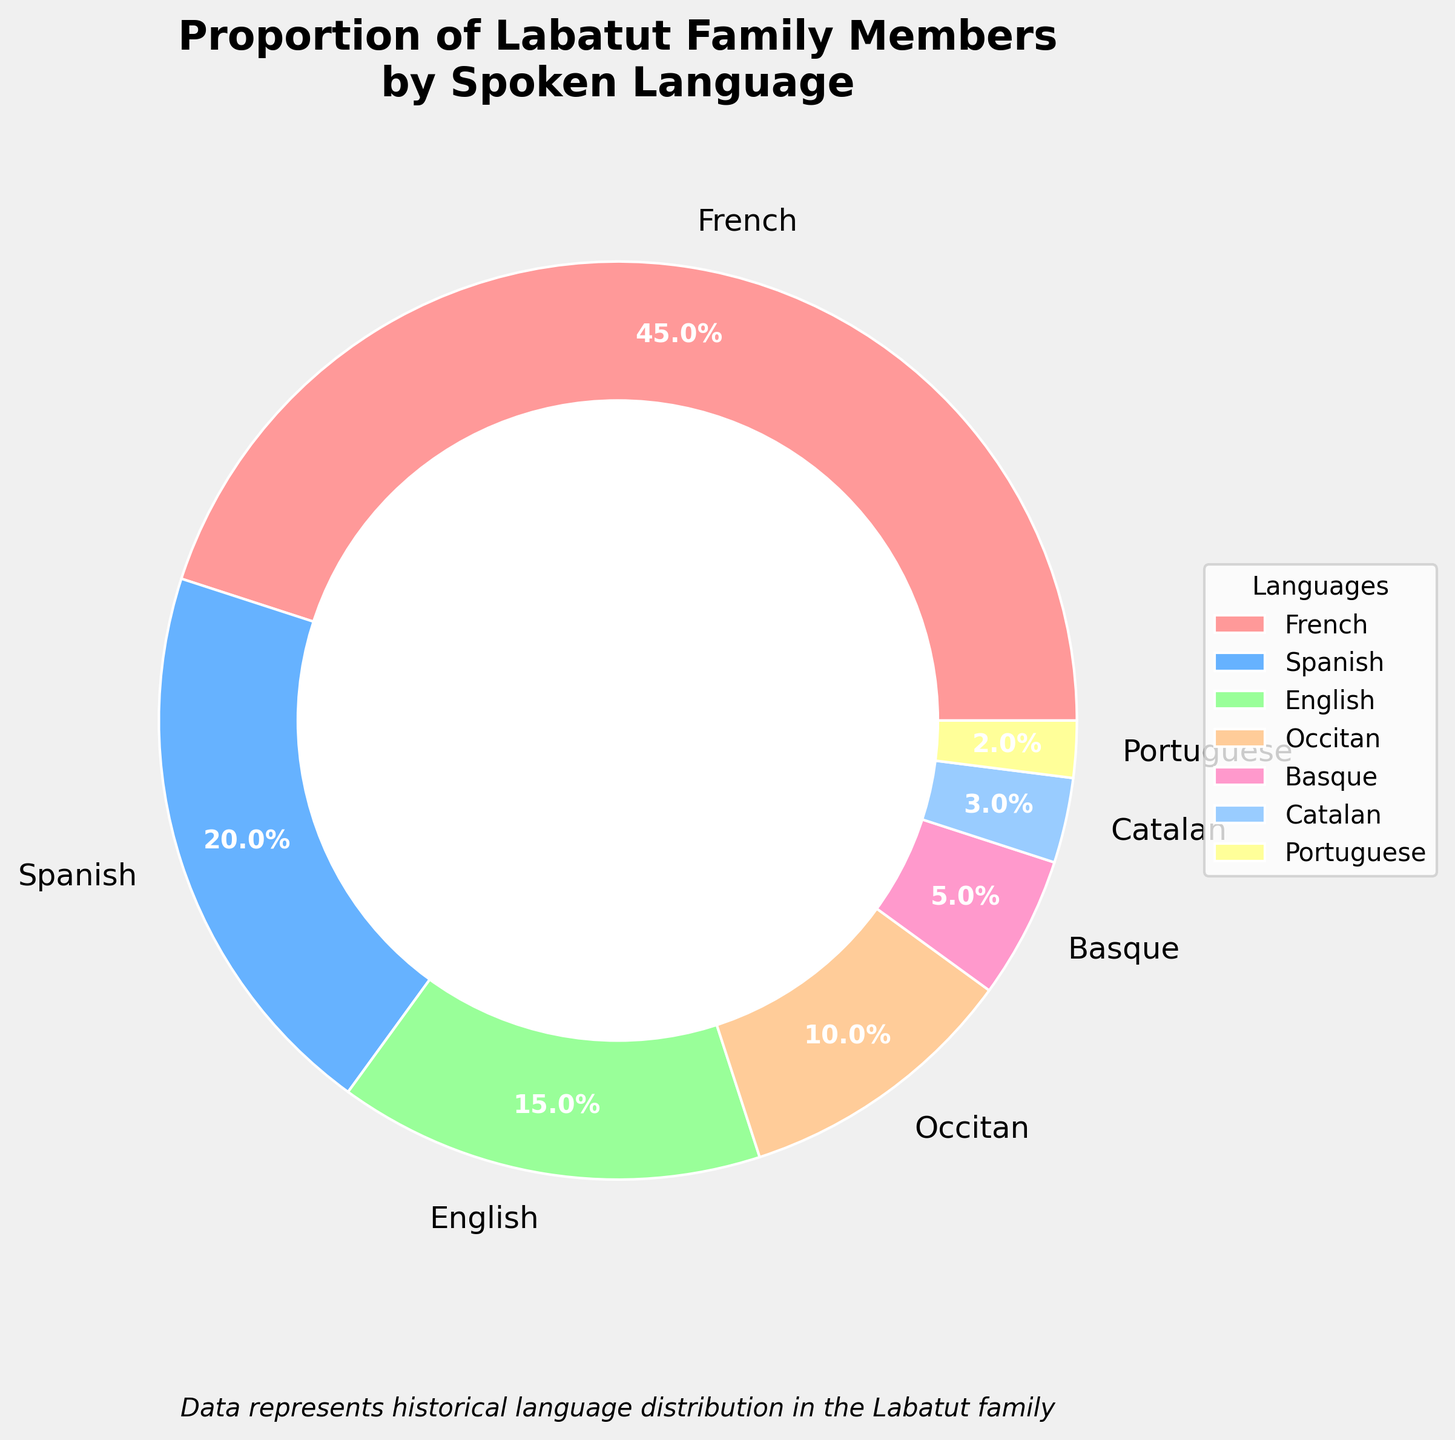What percentage of the Labatut family speaks French? According to the pie chart, the segment labeled "French" represents 45% of the Labatut family.
Answer: 45% Which language is spoken by the least percentage of the Labatut family members? By examining the pie chart, we can see that Portuguese has the smallest segment, representing 2%.
Answer: Portuguese How many languages have a percentage greater than 10% in the Labatut family? The pie chart shows segments for French (45%), Spanish (20%), and English (15%)—three languages that each have a percentage greater than 10%.
Answer: 3 What is the combined percentage of family members who speak Occitan and Catalan? The pie chart shows that Occitan is spoken by 10% and Catalan by 3%. Adding these together (10% + 3%), we get a combined percentage of 13%.
Answer: 13% How does the percentage of family members who speak Spanish compare to those who speak English? The pie chart shows that 20% speak Spanish and 15% speak English. Spanish is spoken by a greater percentage than English.
Answer: Spanish is greater What visual attribute distinguishes the segment representing family members who speak Basque? The Basque segment is visually characterized by its light yellow color in the pie chart.
Answer: Light yellow What is the difference in percentage between the highest and lowest spoken languages in the Labatut family? The chart shows the highest percentage for French (45%) and the lowest for Portuguese (2%). Subtracting these gives a difference of (45% - 2%) = 43%.
Answer: 43% Which languages have percentages that, when added together, exceed the percentage of French speakers? The pie chart shows that Spanish (20%) and English (15%) sum up to 35%, and adding Occitan (10%) gives 35% + 10% = 45%, which equals French; including Basque (5%) makes 50%.
Answer: Spanish, English, and Occitan Is the proportion of family members who speak English more or less than one third of those who speak French? A third of the members who speak French is 45% / 3 = 15%. The chart shows that 15% speak English, which equals one third of French speakers.
Answer: Equal 